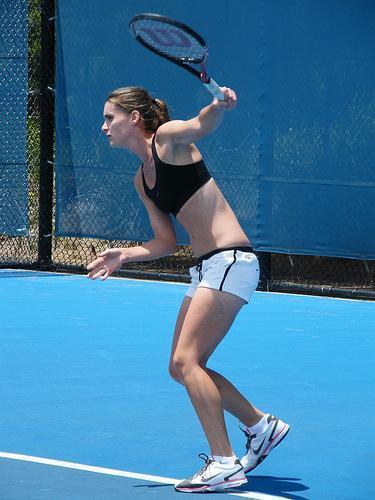How many people are there?
Give a very brief answer. 1. 